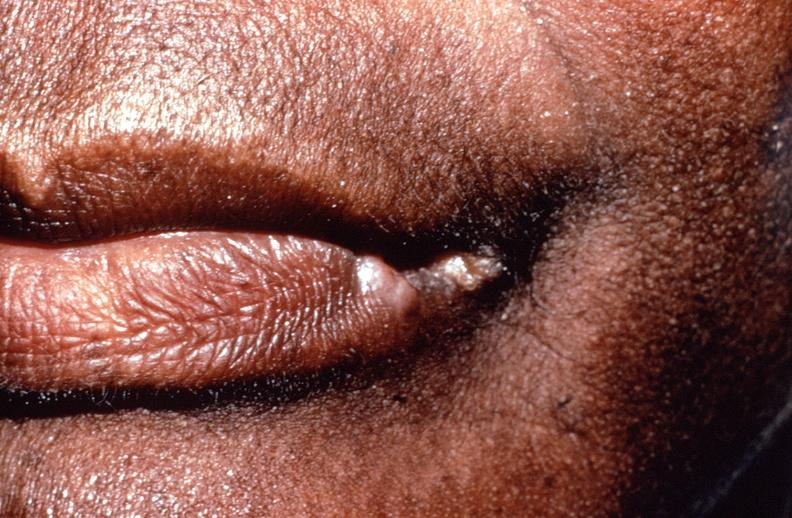s thecoma present?
Answer the question using a single word or phrase. No 